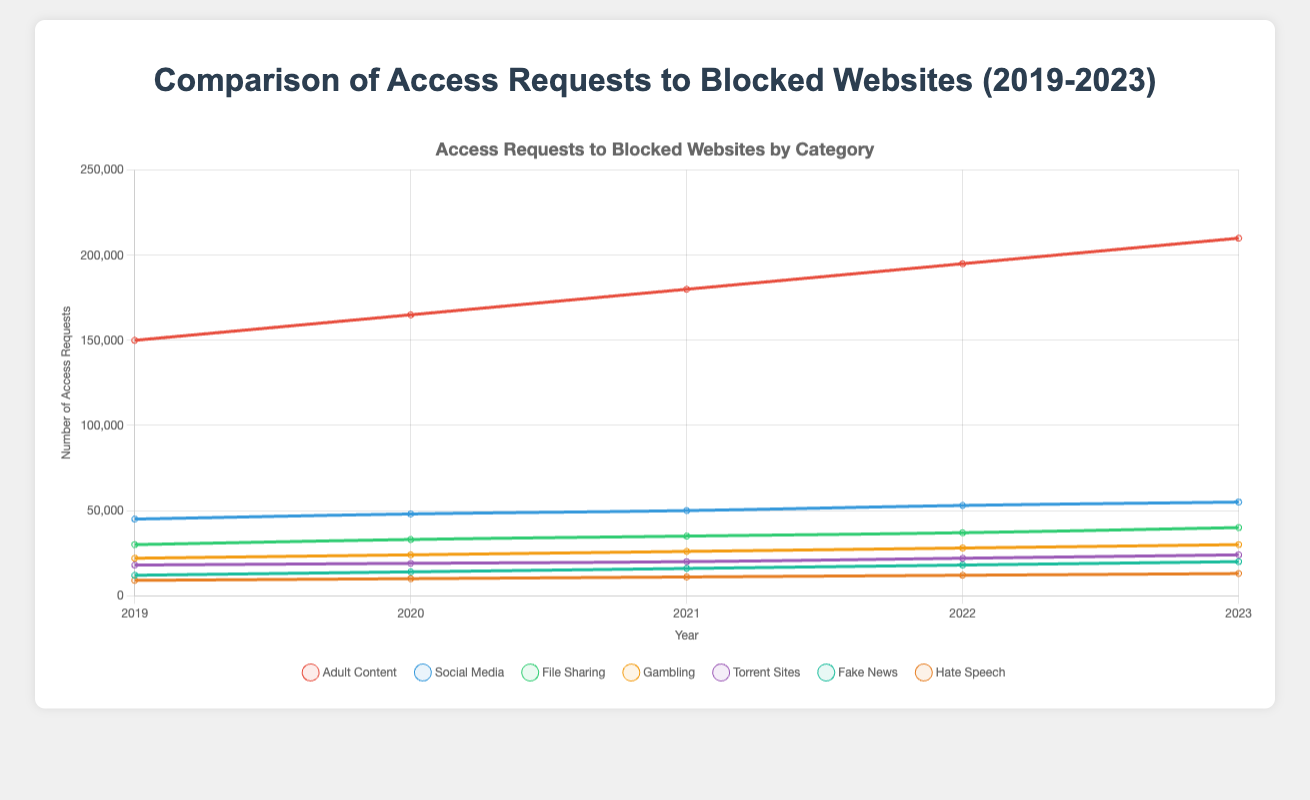What is the trend of access requests for Adult Content from 2019 to 2023? The number of access requests for Adult Content shows a steady increase over the five years. It rises from 150,000 in 2019 to 210,000 in 2023.
Answer: Increasing trend Which category of blocked websites had the highest number of access requests each year? From the line chart, Adult Content consistently had the highest number of access requests each year compared to other categories.
Answer: Adult Content How did the access requests for Social Media in 2021 compare to those in 2019? The chart shows that access requests for Social Media increased from 45,000 in 2019 to 50,000 in 2021.
Answer: Increased What is the difference in the number of access requests between Fake News and Gambling in 2023? Fake News had 20,000 requests, while Gambling had 30,000 requests in 2023. The difference is 30,000 - 20,000 = 10,000.
Answer: 10,000 Which category experienced the most significant increase in access requests from 2019 to 2023? Comparing the starting and ending points for each category, Adult Content had an increase from 150,000 to 210,000, a rise of 60,000, which is the most significant increase.
Answer: Adult Content What is the combined number of access requests for Torrent Sites and File Sharing in 2022? In 2022, Torrent Sites had 22,000 access requests, and File Sharing had 37,000. The combined number is 22,000 + 37,000 = 59,000.
Answer: 59,000 Which category showed the smallest total change in access requests between 2019 and 2023? By checking the initial and final values for each category: Hate Speech increased from 9,000 to 13,000, a change of 4,000, which is the smallest change among all categories.
Answer: Hate Speech Does the number of access requests for Hate Speech ever exceed 15,000 during the observed period? Referring to the chart lines, Hate Speech access requests rose from 9,000 in 2019 to 13,000 in 2023, never exceeding 15,000.
Answer: No In which year did Torrent Sites see the highest number of access requests? The highest number of access requests for Torrent Sites, at 24,000, occurred in 2023, as depicted by the line chart.
Answer: 2023 